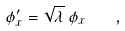Convert formula to latex. <formula><loc_0><loc_0><loc_500><loc_500>\phi ^ { \prime } _ { x } = \sqrt { \lambda } \, \phi _ { x } \quad ,</formula> 